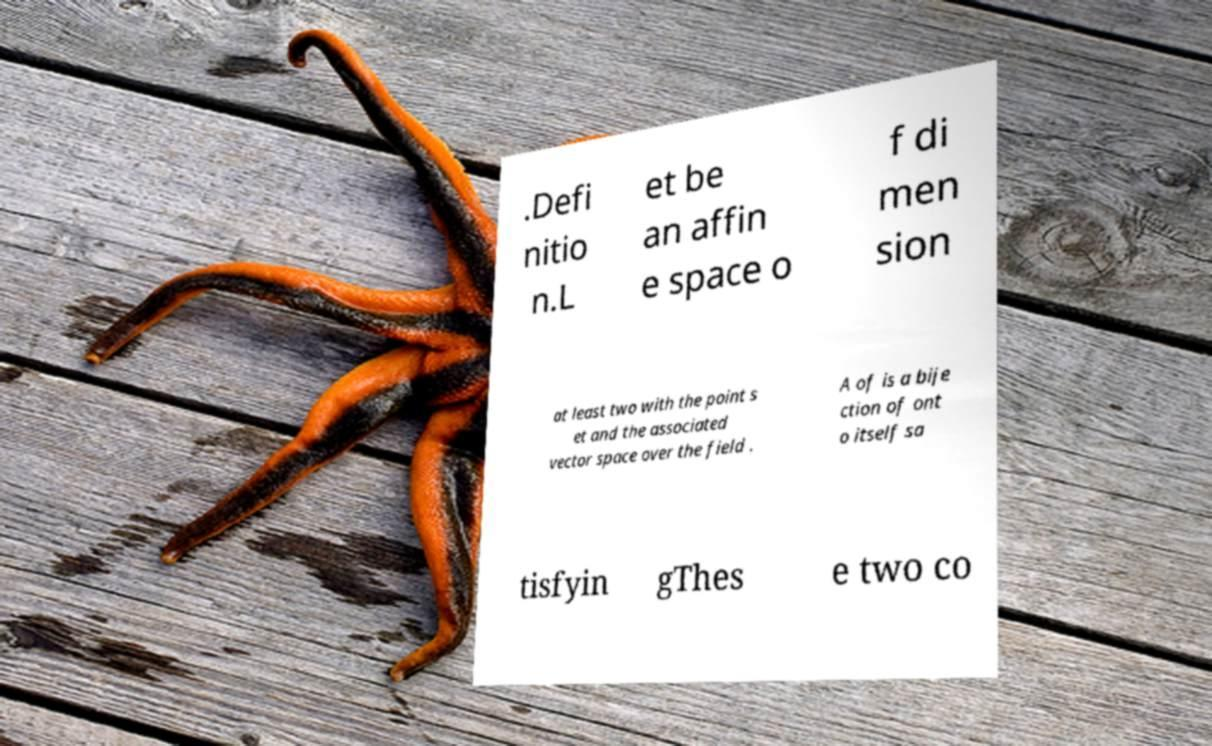Could you extract and type out the text from this image? .Defi nitio n.L et be an affin e space o f di men sion at least two with the point s et and the associated vector space over the field . A of is a bije ction of ont o itself sa tisfyin gThes e two co 